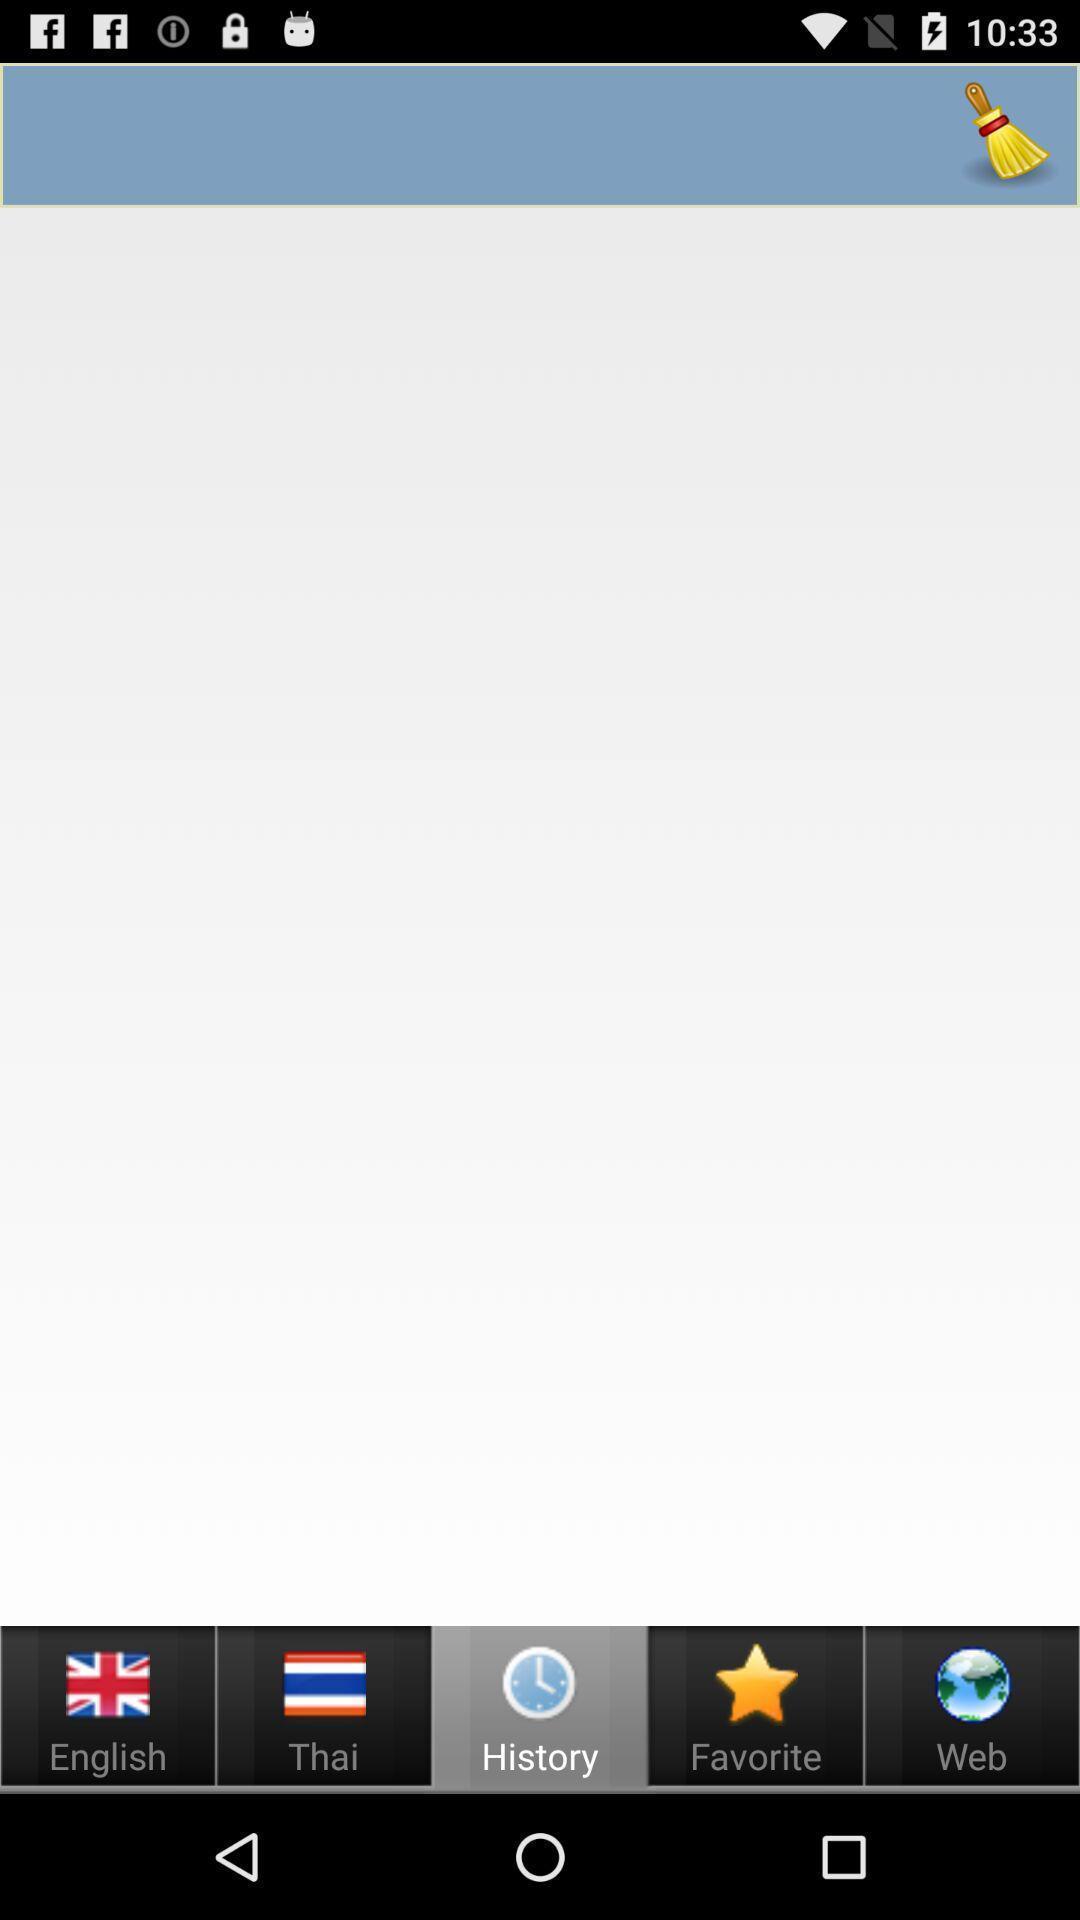Give me a summary of this screen capture. Screen showing history page. 